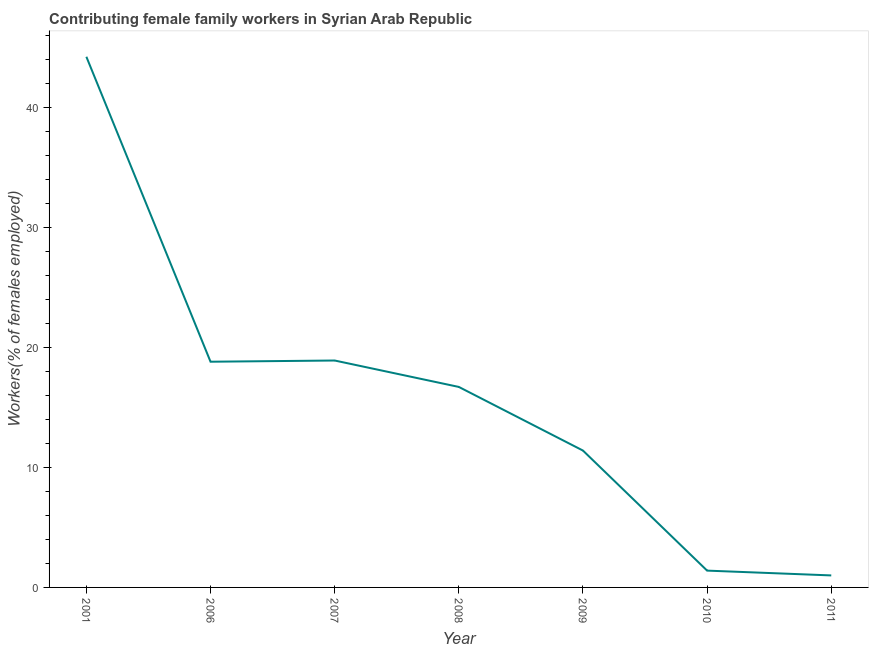What is the contributing female family workers in 2006?
Your answer should be very brief. 18.8. Across all years, what is the maximum contributing female family workers?
Make the answer very short. 44.2. What is the sum of the contributing female family workers?
Keep it short and to the point. 112.4. What is the difference between the contributing female family workers in 2006 and 2010?
Provide a short and direct response. 17.4. What is the average contributing female family workers per year?
Your response must be concise. 16.06. What is the median contributing female family workers?
Your answer should be compact. 16.7. What is the ratio of the contributing female family workers in 2006 to that in 2009?
Provide a short and direct response. 1.65. Is the contributing female family workers in 2001 less than that in 2008?
Your response must be concise. No. Is the difference between the contributing female family workers in 2006 and 2009 greater than the difference between any two years?
Your answer should be compact. No. What is the difference between the highest and the second highest contributing female family workers?
Your answer should be compact. 25.3. Is the sum of the contributing female family workers in 2006 and 2008 greater than the maximum contributing female family workers across all years?
Ensure brevity in your answer.  No. What is the difference between the highest and the lowest contributing female family workers?
Give a very brief answer. 43.2. How many lines are there?
Your answer should be very brief. 1. Are the values on the major ticks of Y-axis written in scientific E-notation?
Keep it short and to the point. No. Does the graph contain any zero values?
Make the answer very short. No. What is the title of the graph?
Make the answer very short. Contributing female family workers in Syrian Arab Republic. What is the label or title of the X-axis?
Your answer should be compact. Year. What is the label or title of the Y-axis?
Your response must be concise. Workers(% of females employed). What is the Workers(% of females employed) in 2001?
Keep it short and to the point. 44.2. What is the Workers(% of females employed) in 2006?
Your answer should be compact. 18.8. What is the Workers(% of females employed) of 2007?
Offer a very short reply. 18.9. What is the Workers(% of females employed) of 2008?
Keep it short and to the point. 16.7. What is the Workers(% of females employed) of 2009?
Give a very brief answer. 11.4. What is the Workers(% of females employed) of 2010?
Your response must be concise. 1.4. What is the difference between the Workers(% of females employed) in 2001 and 2006?
Provide a short and direct response. 25.4. What is the difference between the Workers(% of females employed) in 2001 and 2007?
Your answer should be very brief. 25.3. What is the difference between the Workers(% of females employed) in 2001 and 2008?
Give a very brief answer. 27.5. What is the difference between the Workers(% of females employed) in 2001 and 2009?
Your answer should be very brief. 32.8. What is the difference between the Workers(% of females employed) in 2001 and 2010?
Your answer should be very brief. 42.8. What is the difference between the Workers(% of females employed) in 2001 and 2011?
Offer a terse response. 43.2. What is the difference between the Workers(% of females employed) in 2006 and 2007?
Make the answer very short. -0.1. What is the difference between the Workers(% of females employed) in 2006 and 2008?
Your answer should be compact. 2.1. What is the difference between the Workers(% of females employed) in 2007 and 2009?
Keep it short and to the point. 7.5. What is the difference between the Workers(% of females employed) in 2007 and 2011?
Provide a succinct answer. 17.9. What is the difference between the Workers(% of females employed) in 2008 and 2009?
Your answer should be compact. 5.3. What is the difference between the Workers(% of females employed) in 2008 and 2011?
Give a very brief answer. 15.7. What is the difference between the Workers(% of females employed) in 2009 and 2011?
Offer a very short reply. 10.4. What is the ratio of the Workers(% of females employed) in 2001 to that in 2006?
Ensure brevity in your answer.  2.35. What is the ratio of the Workers(% of females employed) in 2001 to that in 2007?
Offer a very short reply. 2.34. What is the ratio of the Workers(% of females employed) in 2001 to that in 2008?
Give a very brief answer. 2.65. What is the ratio of the Workers(% of females employed) in 2001 to that in 2009?
Your response must be concise. 3.88. What is the ratio of the Workers(% of females employed) in 2001 to that in 2010?
Your answer should be very brief. 31.57. What is the ratio of the Workers(% of females employed) in 2001 to that in 2011?
Your answer should be very brief. 44.2. What is the ratio of the Workers(% of females employed) in 2006 to that in 2008?
Keep it short and to the point. 1.13. What is the ratio of the Workers(% of females employed) in 2006 to that in 2009?
Offer a very short reply. 1.65. What is the ratio of the Workers(% of females employed) in 2006 to that in 2010?
Provide a succinct answer. 13.43. What is the ratio of the Workers(% of females employed) in 2007 to that in 2008?
Provide a short and direct response. 1.13. What is the ratio of the Workers(% of females employed) in 2007 to that in 2009?
Offer a terse response. 1.66. What is the ratio of the Workers(% of females employed) in 2007 to that in 2011?
Provide a short and direct response. 18.9. What is the ratio of the Workers(% of females employed) in 2008 to that in 2009?
Ensure brevity in your answer.  1.47. What is the ratio of the Workers(% of females employed) in 2008 to that in 2010?
Your answer should be very brief. 11.93. What is the ratio of the Workers(% of females employed) in 2008 to that in 2011?
Offer a terse response. 16.7. What is the ratio of the Workers(% of females employed) in 2009 to that in 2010?
Your answer should be compact. 8.14. What is the ratio of the Workers(% of females employed) in 2010 to that in 2011?
Offer a very short reply. 1.4. 